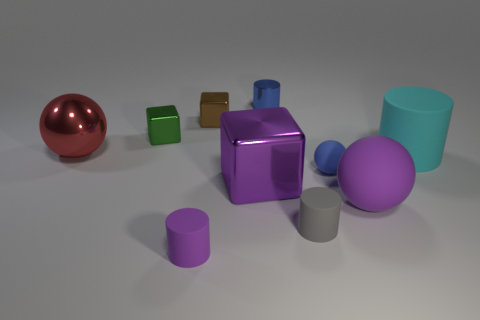Subtract all big purple shiny cubes. How many cubes are left? 2 Subtract all cyan cylinders. How many cylinders are left? 3 Subtract all big rubber blocks. Subtract all tiny matte cylinders. How many objects are left? 8 Add 9 tiny purple cylinders. How many tiny purple cylinders are left? 10 Add 7 big matte cylinders. How many big matte cylinders exist? 8 Subtract 0 cyan spheres. How many objects are left? 10 Subtract all cylinders. How many objects are left? 6 Subtract all green spheres. Subtract all yellow cylinders. How many spheres are left? 3 